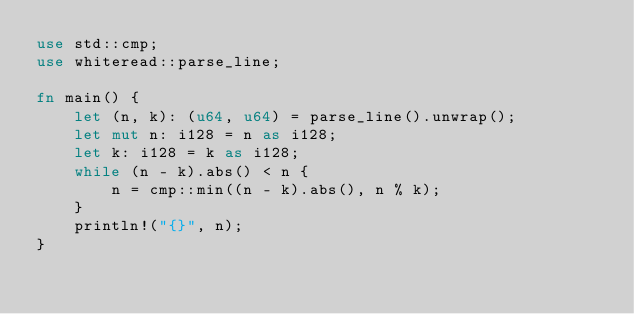<code> <loc_0><loc_0><loc_500><loc_500><_Rust_>use std::cmp;
use whiteread::parse_line;

fn main() {
    let (n, k): (u64, u64) = parse_line().unwrap();
    let mut n: i128 = n as i128;
    let k: i128 = k as i128;
    while (n - k).abs() < n {
        n = cmp::min((n - k).abs(), n % k);
    }
    println!("{}", n);
}
</code> 